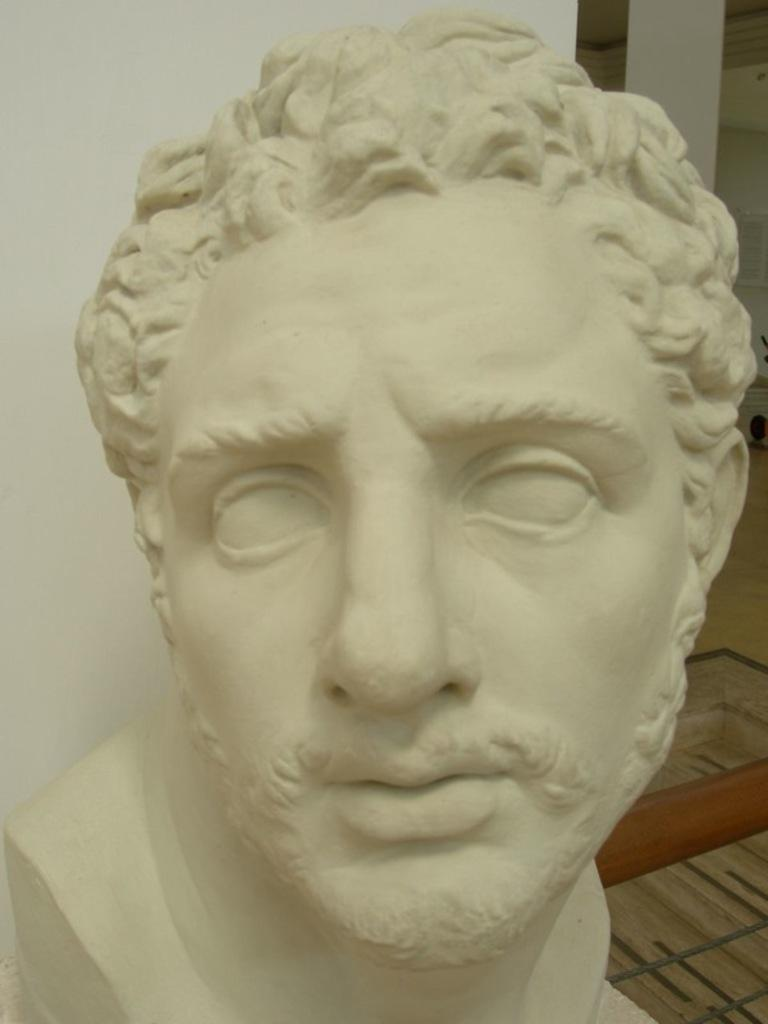What is the main subject of the image? There is a sculpture of a person in the image. Can you describe the sculpture in more detail? Unfortunately, the facts provided do not give any additional details about the sculpture. What else can be seen in the image besides the sculpture? There are other objects in the background of the image. What type of cent is depicted in the sculpture? There is no cent present in the image, as the main subject is a sculpture of a person. What is the fuel source for the iron in the sculpture? There is no iron or fuel source mentioned in the image, as the main subject is a sculpture of a person. 